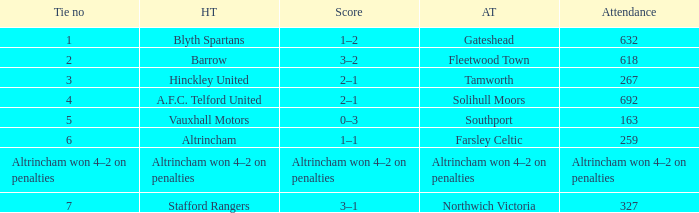What was the score when there were 7 ties? 3–1. 